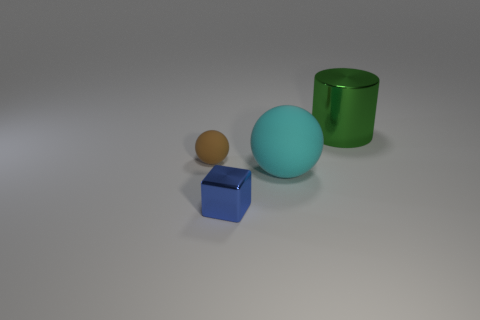Add 4 tiny balls. How many objects exist? 8 Subtract all cylinders. How many objects are left? 3 Subtract 0 purple cylinders. How many objects are left? 4 Subtract all large red shiny balls. Subtract all tiny spheres. How many objects are left? 3 Add 2 large green metal cylinders. How many large green metal cylinders are left? 3 Add 4 brown objects. How many brown objects exist? 5 